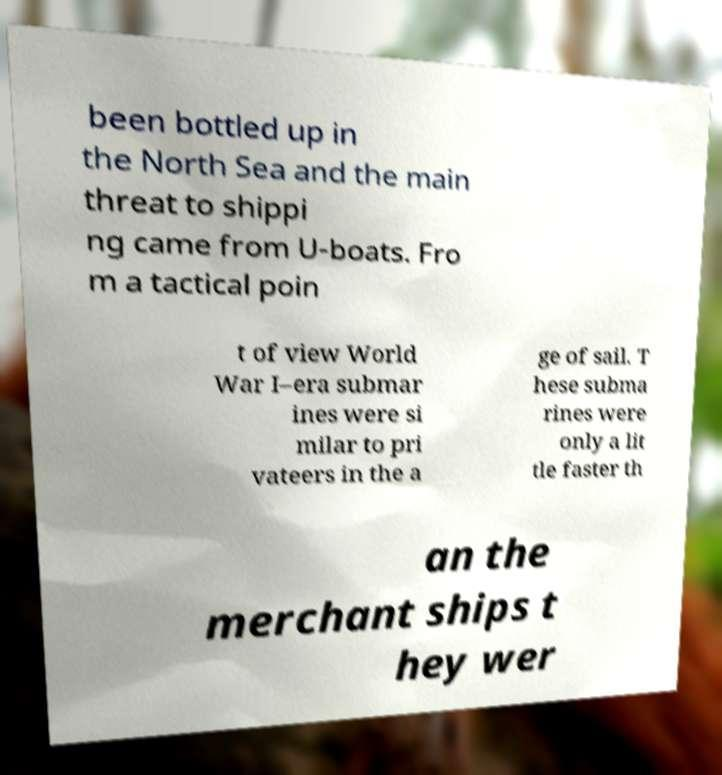Please identify and transcribe the text found in this image. been bottled up in the North Sea and the main threat to shippi ng came from U-boats. Fro m a tactical poin t of view World War I–era submar ines were si milar to pri vateers in the a ge of sail. T hese subma rines were only a lit tle faster th an the merchant ships t hey wer 